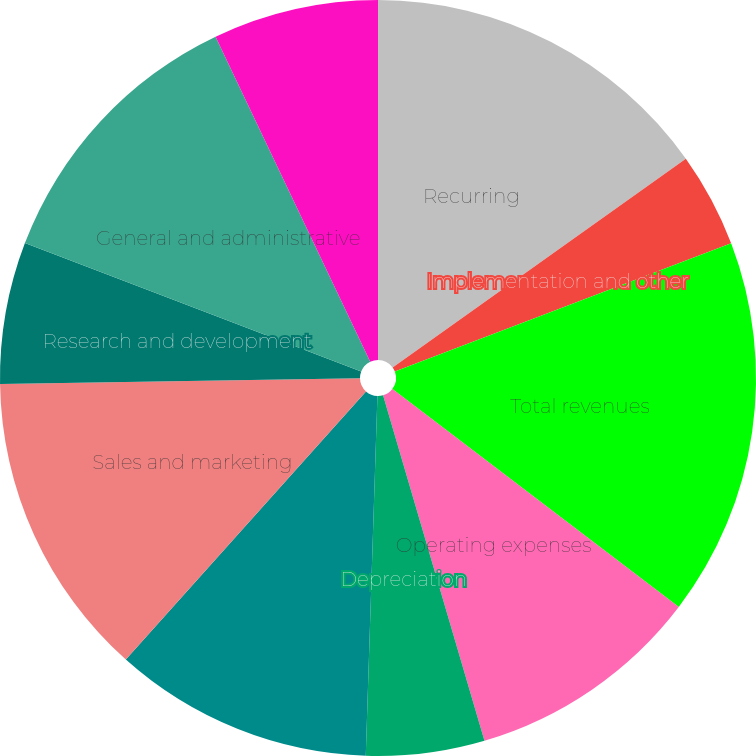Convert chart to OTSL. <chart><loc_0><loc_0><loc_500><loc_500><pie_chart><fcel>Recurring<fcel>Implementation and other<fcel>Total revenues<fcel>Operating expenses<fcel>Depreciation<fcel>Total cost of revenues<fcel>Sales and marketing<fcel>Research and development<fcel>General and administrative<fcel>Depreciation and amortization<nl><fcel>15.15%<fcel>4.05%<fcel>16.16%<fcel>10.1%<fcel>5.06%<fcel>11.11%<fcel>13.13%<fcel>6.06%<fcel>12.12%<fcel>7.07%<nl></chart> 